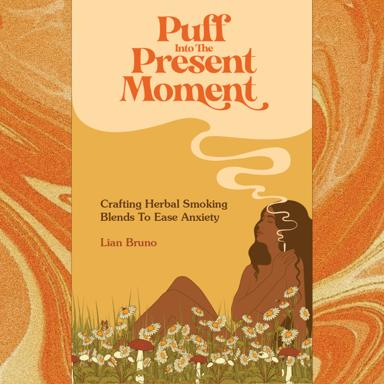What inspired the author to write about herbal smoking blends for anxiety relief? The inspiration likely comes from growing awareness and appreciation of natural health remedies. Herbal smoking blends, as described in this book, offer a non-pharmaceutical method to manage anxiety, aligning with broader trends towards mindfulness and natural wellness. 